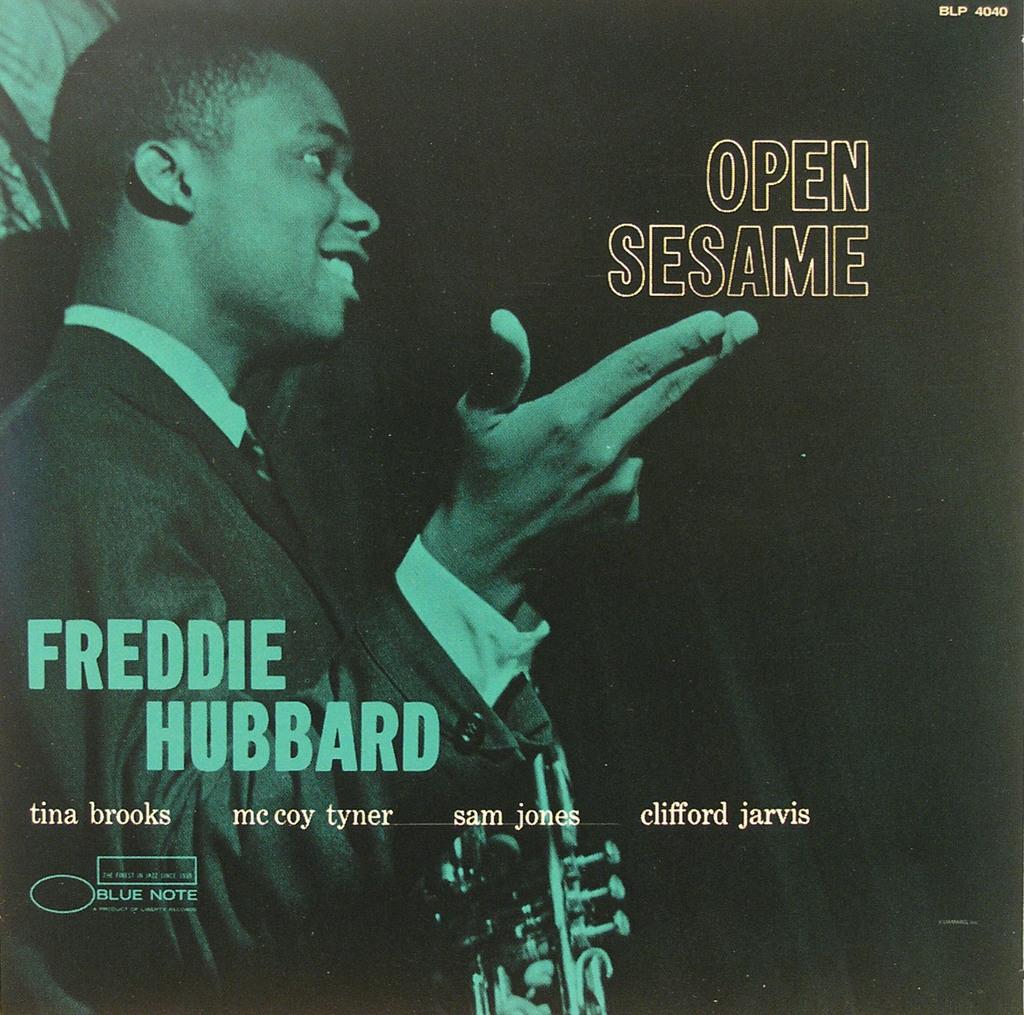What musician is featured here?
Offer a terse response. Freddie hubbard. What is the title of this album?
Your answer should be very brief. Open sesame. 